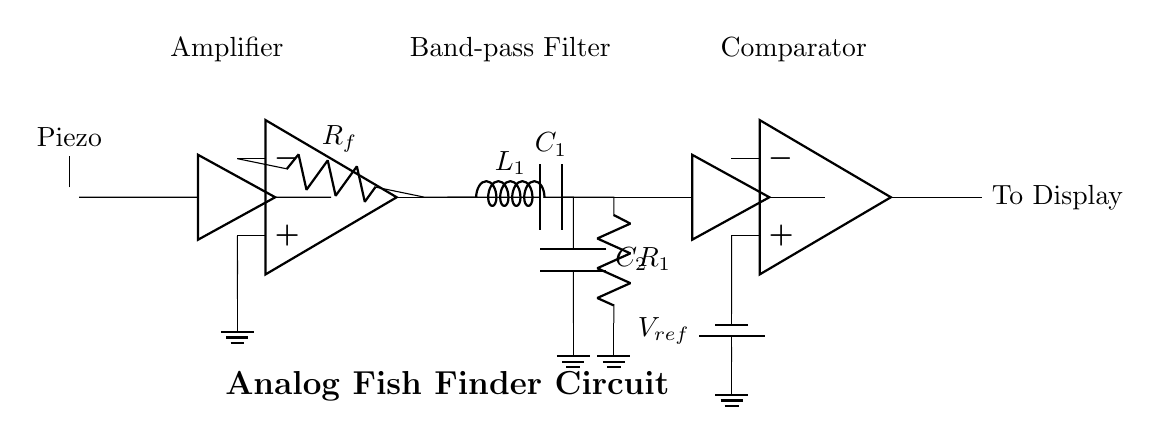What type of transducer is used in this circuit? The circuit uses a piezoelectric transducer, indicated by the specific symbol labeled "Piezo" in the circuit diagram.
Answer: Piezoelectric What component amplifies the signal? The op-amp, depicted in the circuit diagram, is responsible for amplifying the signal from the piezoelectric transducer.
Answer: Op-amp What does the band-pass filter consist of? The band-pass filter is made up of a resistor and two capacitors, specifically labeled as R1, C1, and C2 in the circuit diagram.
Answer: Resistor and capacitors What is the purpose of the comparator in the circuit? The comparator compares the amplified signal voltage to a reference voltage, allowing it to determine the presence or absence of fish based on the output signal.
Answer: Comparison What type of circuit is this diagram illustrating? This diagram illustrates an analog circuit designed for fish finding, incorporating analog signal processing elements such as amplification, filtering, and comparison.
Answer: Analog fish finder What is the reference voltage used in the comparator? The reference voltage denoted by "V_ref" in the circuit shows the voltage used by the comparator for reference when analyzing the input signal.
Answer: V_ref How many main functional blocks are present in this circuit? There are three main functional blocks in the circuit: the amplifier, the band-pass filter, and the comparator, each serving distinct purposes in the signal processing chain.
Answer: Three 